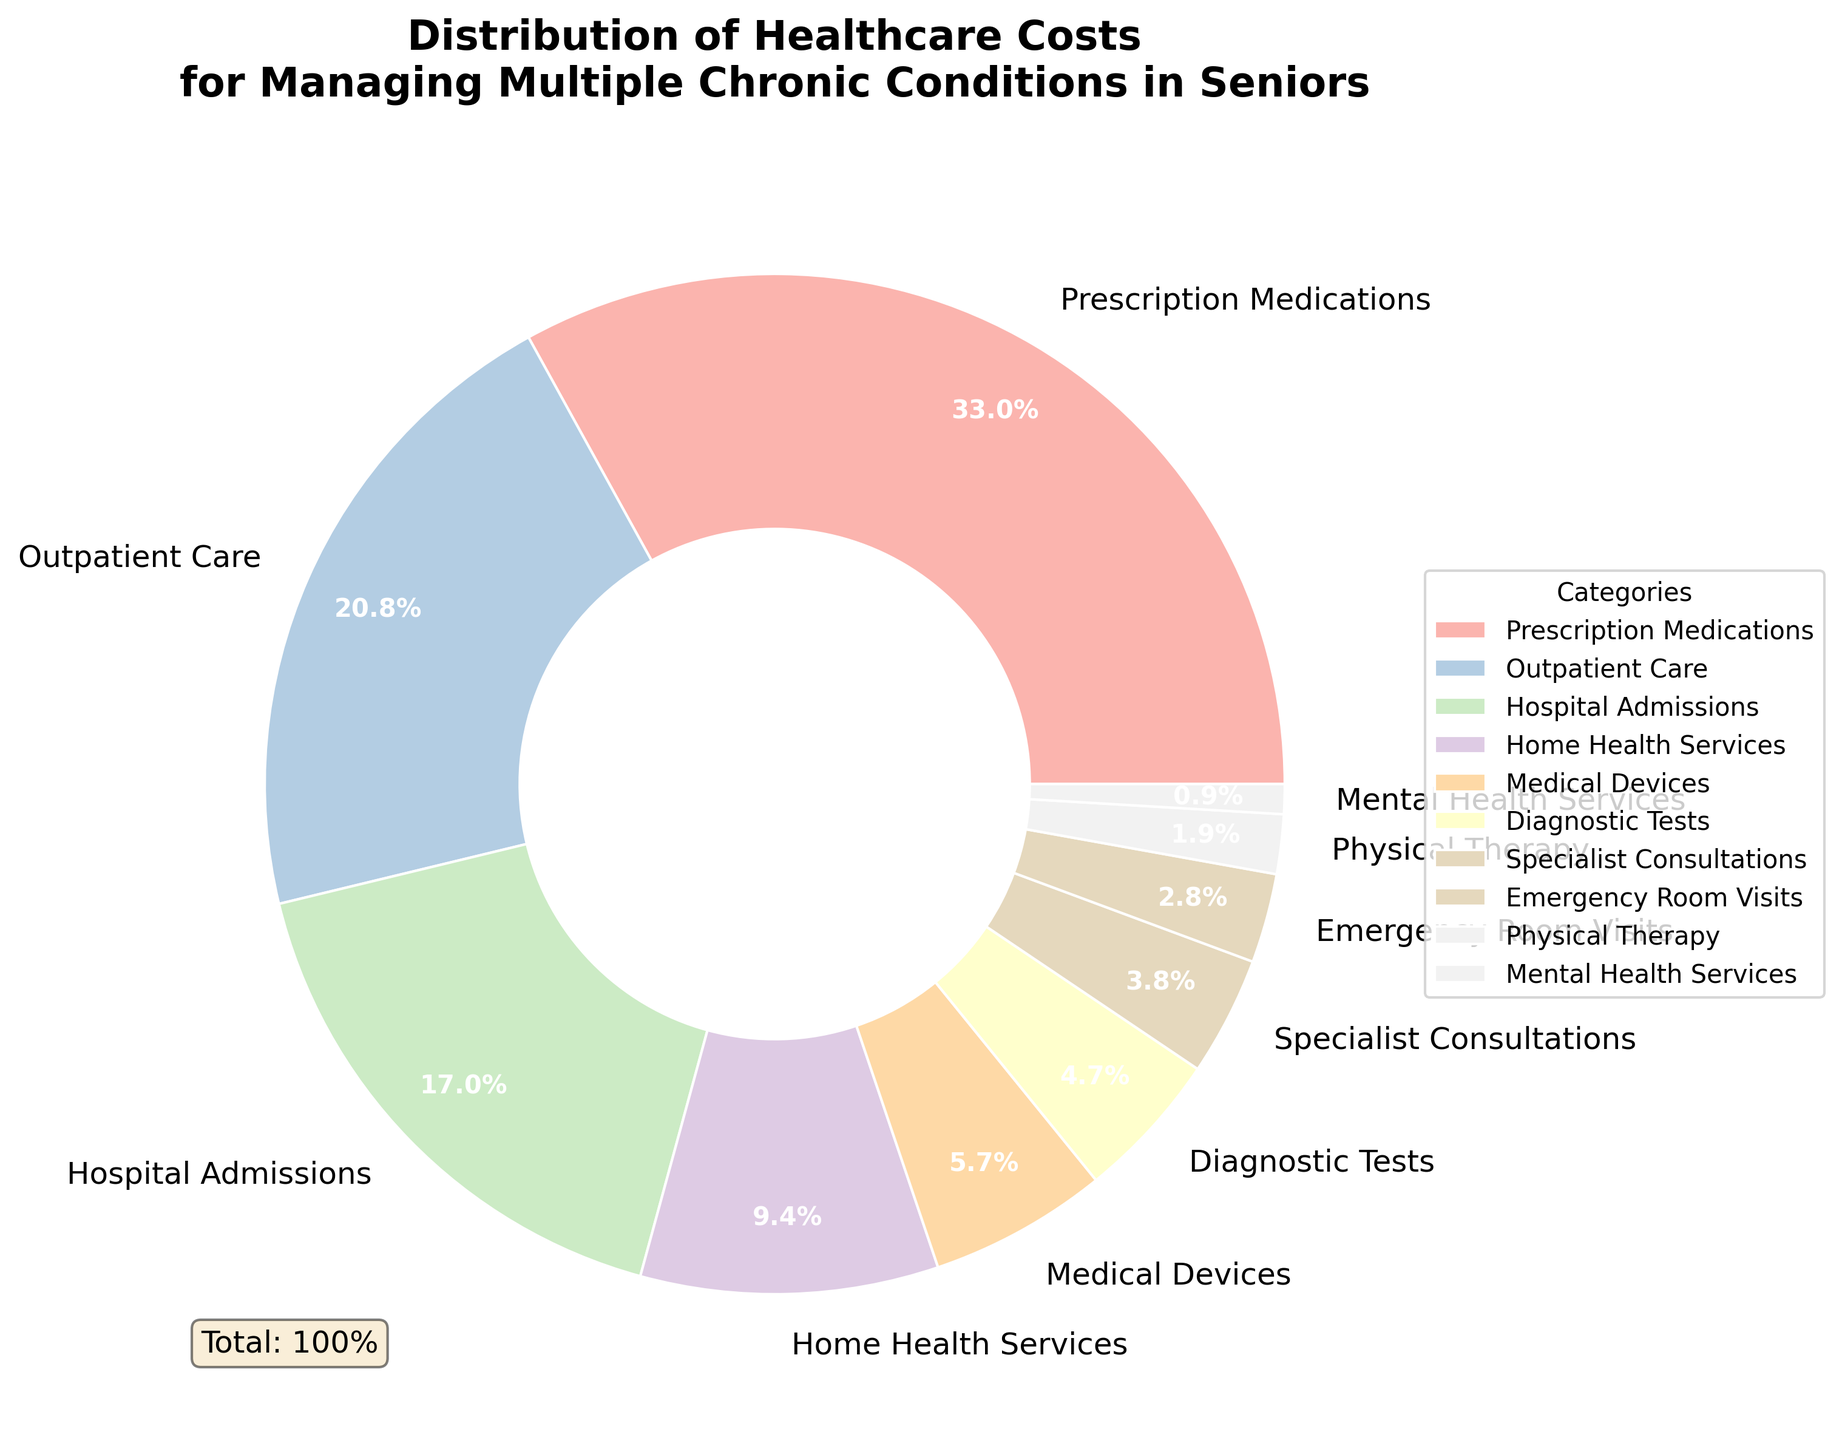What category has the highest percentage of healthcare costs? The pie chart shows the healthcare cost distribution among different categories. The largest wedge corresponds to "Prescription Medications" at 35%.
Answer: Prescription Medications What is the combined percentage of Hospital Admissions and Home Health Services? The figure shows that Hospital Admissions account for 18% and Home Health Services account for 10%. Adding these together, we get 18 + 10 = 28%.
Answer: 28% How does the percentage of Outpatient Care compare to Emergency Room Visits? In the pie chart, Outpatient Care is listed at 22%, whereas Emergency Room Visits are at 3%. Therefore, Outpatient Care is greater than Emergency Room Visits.
Answer: Outpatient Care is greater Which category has the smallest portion of healthcare costs? Examining the chart, the smallest slice is for "Mental Health Services" at 1%.
Answer: Mental Health Services What is the difference in percentage between Prescription Medications and Medical Devices? From the chart, Prescription Medications are at 35%, and Medical Devices are at 6%. The difference is 35 - 6 = 29%.
Answer: 29% Are Diagnostic Tests and Physical Therapy equal in their percentage of costs? The chart indicates Diagnostic Tests at 5% and Physical Therapy at 2%. These values are not equal.
Answer: No What is the total percentage for the combined costs of Specialist Consultations, Emergency Room Visits, and Mental Health Services? The percentages for Specialist Consultations, Emergency Room Visits, and Mental Health Services are 4%, 3%, and 1% respectively. Adding them together, we get 4 + 3 + 1 = 8%.
Answer: 8% Which two categories combined account for more than half of the total healthcare costs? By observing the chart, Prescription Medications (35%) and Outpatient Care (22%) combined account for 35 + 22 = 57%, which is more than half (50%).
Answer: Prescription Medications and Outpatient Care If you combine the costs for Outpatient Care, Hospital Admissions, and Home Health Services, what percentage of the total costs do they represent? The chart lists Outpatient Care at 22%, Hospital Admissions at 18%, and Home Health Services at 10%. Their sum is 22 + 18 + 10 = 50%.
Answer: 50% What visual attribute indicates the highest healthcare cost category? The pie chart's largest slice is the visual attribute that indicates the highest cost category, which corresponds to Prescription Medications.
Answer: The largest slice 